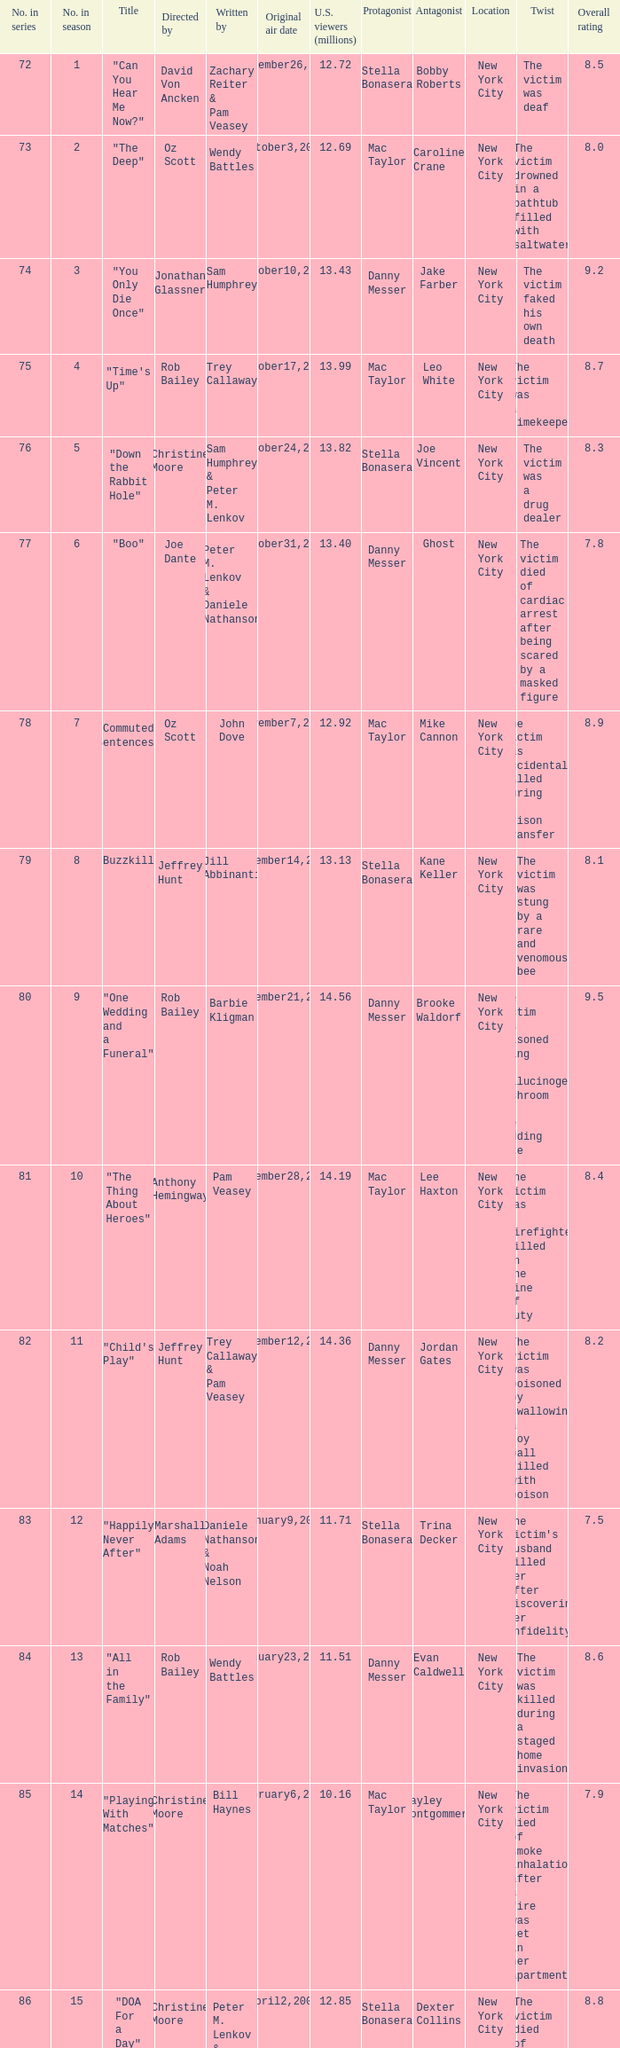How many millions of U.S. viewers watched the episode directed by Rob Bailey and written by Pam Veasey? 12.38. Parse the table in full. {'header': ['No. in series', 'No. in season', 'Title', 'Directed by', 'Written by', 'Original air date', 'U.S. viewers (millions)', 'Protagonist', 'Antagonist', 'Location', 'Twist', 'Overall rating'], 'rows': [['72', '1', '"Can You Hear Me Now?"', 'David Von Ancken', 'Zachary Reiter & Pam Veasey', 'September26,2007', '12.72', 'Stella Bonasera', 'Bobby Roberts', 'New York City', 'The victim was deaf', '8.5'], ['73', '2', '"The Deep"', 'Oz Scott', 'Wendy Battles', 'October3,2007', '12.69', 'Mac Taylor', 'Caroline Crane', 'New York City', 'The victim drowned in a bathtub filled with saltwater', '8.0'], ['74', '3', '"You Only Die Once"', 'Jonathan Glassner', 'Sam Humphrey', 'October10,2007', '13.43', 'Danny Messer', 'Jake Farber', 'New York City', 'The victim faked his own death', '9.2'], ['75', '4', '"Time\'s Up"', 'Rob Bailey', 'Trey Callaway', 'October17,2007', '13.99', 'Mac Taylor', 'Leo White', 'New York City', 'The victim was a timekeeper', '8.7'], ['76', '5', '"Down the Rabbit Hole"', 'Christine Moore', 'Sam Humphrey & Peter M. Lenkov', 'October24,2007', '13.82', 'Stella Bonasera', 'Joe Vincent', 'New York City', 'The victim was a drug dealer', '8.3'], ['77', '6', '"Boo"', 'Joe Dante', 'Peter M. Lenkov & Daniele Nathanson', 'October31,2007', '13.40', 'Danny Messer', 'Ghost', 'New York City', 'The victim died of cardiac arrest after being scared by a masked figure', '7.8'], ['78', '7', '"Commuted Sentences"', 'Oz Scott', 'John Dove', 'November7,2007', '12.92', 'Mac Taylor', 'Mike Cannon', 'New York City', 'The victim was accidentally killed during a prison transfer', '8.9'], ['79', '8', '"Buzzkill"', 'Jeffrey Hunt', 'Jill Abbinanti', 'November14,2007', '13.13', 'Stella Bonasera', 'Kane Keller', 'New York City', 'The victim was stung by a rare and venomous bee', '8.1'], ['80', '9', '"One Wedding and a Funeral"', 'Rob Bailey', 'Barbie Kligman', 'November21,2007', '14.56', 'Danny Messer', 'Brooke Waldorf', 'New York City', 'The victim was poisoned using a hallucinogenic mushroom in the wedding cake', '9.5'], ['81', '10', '"The Thing About Heroes"', 'Anthony Hemingway', 'Pam Veasey', 'November28,2007', '14.19', 'Mac Taylor', 'Lee Haxton', 'New York City', 'The victim was a firefighter killed in the line of duty', '8.4'], ['82', '11', '"Child\'s Play"', 'Jeffrey Hunt', 'Trey Callaway & Pam Veasey', 'December12,2007', '14.36', 'Danny Messer', 'Jordan Gates', 'New York City', 'The victim was poisoned by swallowing a toy ball filled with poison', '8.2'], ['83', '12', '"Happily Never After"', 'Marshall Adams', 'Daniele Nathanson & Noah Nelson', 'January9,2008', '11.71', 'Stella Bonasera', 'Trina Decker', 'New York City', "The victim's husband killed her after discovering her infidelity", '7.5'], ['84', '13', '"All in the Family"', 'Rob Bailey', 'Wendy Battles', 'January23,2008', '11.51', 'Danny Messer', 'Evan Caldwell', 'New York City', 'The victim was killed during a staged home invasion', '8.6'], ['85', '14', '"Playing With Matches"', 'Christine Moore', 'Bill Haynes', 'February6,2008', '10.16', 'Mac Taylor', 'Hayley Montgommery', 'New York City', 'The victim died of smoke inhalation after a fire was set in her apartment', '7.9'], ['86', '15', '"DOA For a Day"', 'Christine Moore', 'Peter M. Lenkov & John Dove', 'April2,2008', '12.85', 'Stella Bonasera', 'Dexter Collins', 'New York City', 'The victim died of an overdose but was moved to a different location', '8.8'], ['87', '16', '"Right Next Door"', 'Rob Bailey', 'Pam Veasey', 'April9,2008', '12.38', 'Danny Messer', 'Pamela Adler', 'New York City', "The victim's neighbor was responsible for her death", '8.0'], ['88', '17', '"Like Water For Murder"', 'Anthony Hemingway', 'Sam Humphrey', 'April16,2008', '13.43', 'Mac Taylor', 'Frank Ivanek', 'New York City', 'The victim was drowned in a bathtub filled with olive oil', '8.3'], ['89', '18', '"Admissions"', 'Rob Bailey', 'Zachary Reiter', 'April30,2008', '11.51', 'Stella Bonasera', 'Heather Kessler', 'New York City', 'The victim was killed by an unknown pathogen', '7.6'], ['90', '19', '"Personal Foul"', 'David Von Ancken', 'Trey Callaway', 'May7,2008', '12.73', 'Danny Messer', 'Clay Dobson', 'New York City', 'The victim was a high school basketball coach killed over a recruiting scandal', '8.9'], ['91', '20', '"Taxi"', 'Christine Moore', 'Barbie Kligman & John Dove', 'May14,2008', '11.86', 'Mac Taylor', 'Reynaldo Cortez', 'New York City', 'The victim was a taxi driver killed during a robbery gone wrong', '8.1']]} 